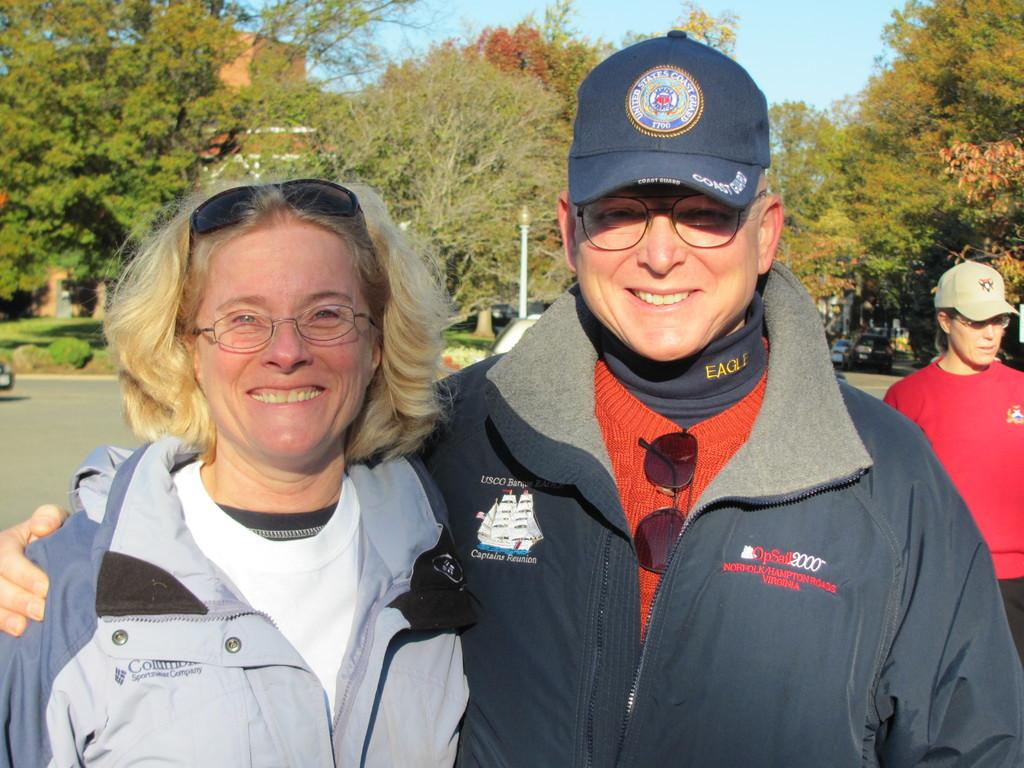How many people are in the image? There are three people standing in the image. What is the facial expression of the people in the image? Two of the people are smiling. What accessory do the smiling people have in common? Both smiling people are wearing glasses. What type of natural environment is visible in the background of the image? There are trees and grass in the background of the image. What man-made structures can be seen in the background of the image? Vehicles and a light on a pole are present in the background of the image. What part of the natural environment is visible in the image? The sky is visible in the background of the image. What type of yak can be seen in the image? There is no yak present in the image. Is there a birthday celebration happening in the image? There is no indication of a birthday celebration in the image. 